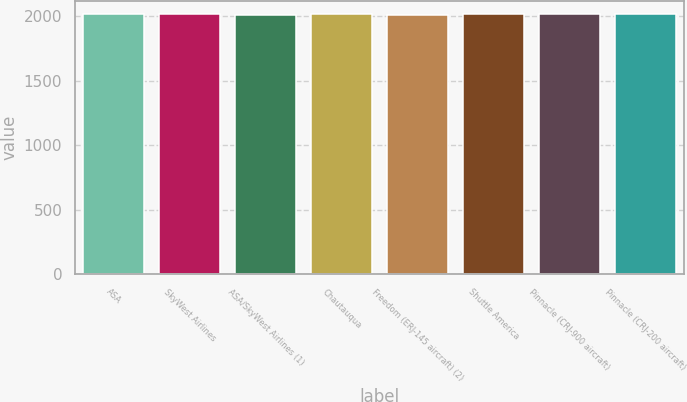Convert chart. <chart><loc_0><loc_0><loc_500><loc_500><bar_chart><fcel>ASA<fcel>SkyWest Airlines<fcel>ASA/SkyWest Airlines (1)<fcel>Chautauqua<fcel>Freedom (ERJ-145 aircraft) (2)<fcel>Shuttle America<fcel>Pinnacle (CRJ-900 aircraft)<fcel>Pinnacle (CRJ-200 aircraft)<nl><fcel>2020.6<fcel>2021.4<fcel>2012<fcel>2016<fcel>2012.8<fcel>2019<fcel>2019.8<fcel>2017<nl></chart> 